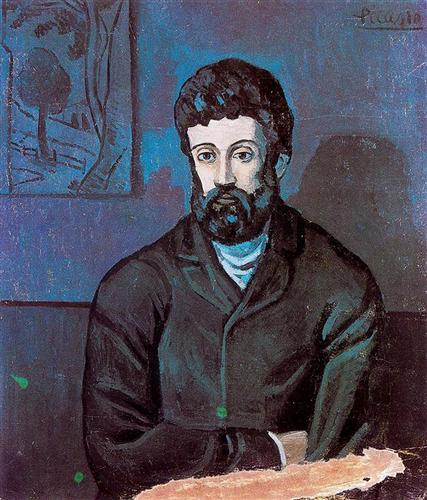Assume the portrait was painted in Picasso's studio. Describe the studio environment during the creation of this artwork. Picasso’s studio during the creation of this artwork would likely have been a space filled with creative energy and diverse influences. The room might have been dimly lit, allowing only natural light to filter in through large windows, accentuating the shadows and highlights in the work. Paints, brushes, and sketches might be scattered around, each contributing to the evolving masterpiece. The walls could be adorned with previous artworks and sources of inspiration, providing a complex backdrop for the artist's creative process. The air would be thick with the smell of oil paints, and the room would hum with a focused, almost sacred silence only occasionally broken by the artist’s movements. 